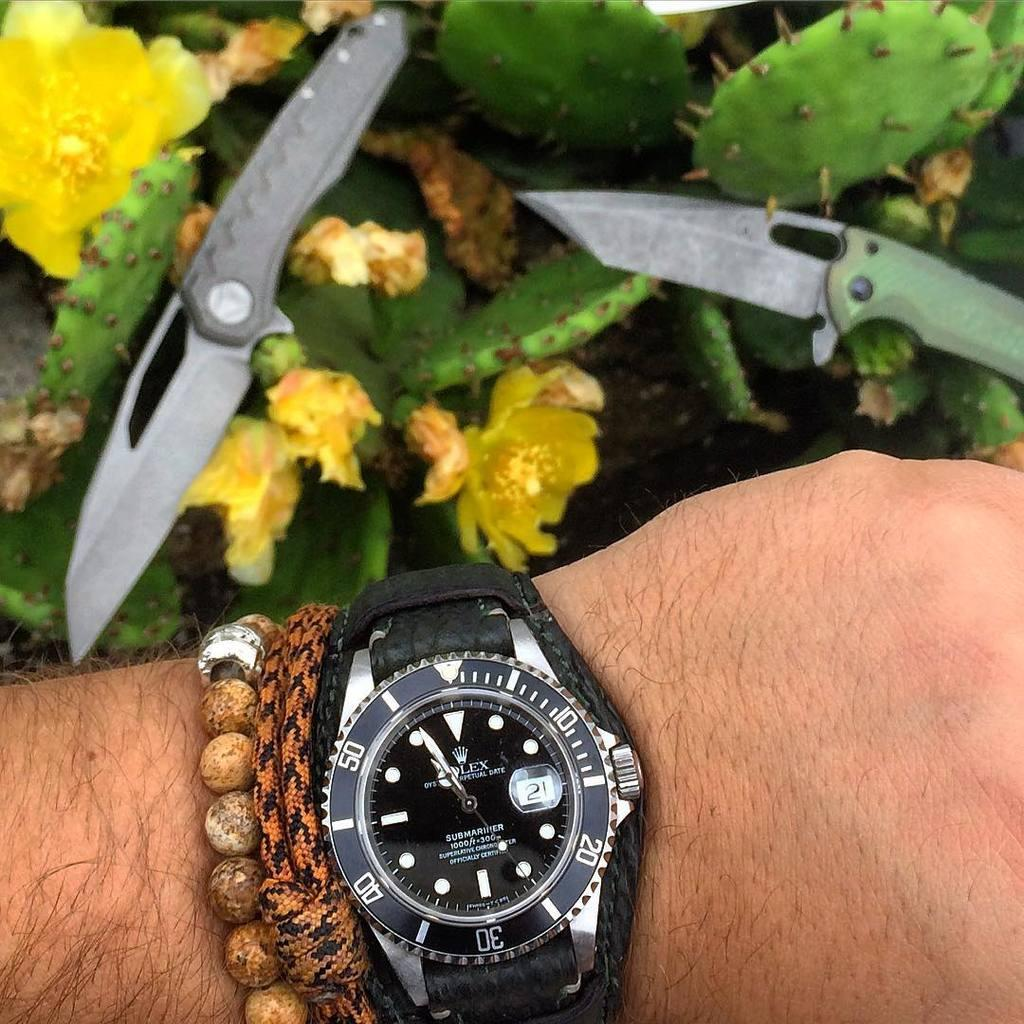Provide a one-sentence caption for the provided image. Person wearing a watch that has the number 21 on the screen. 